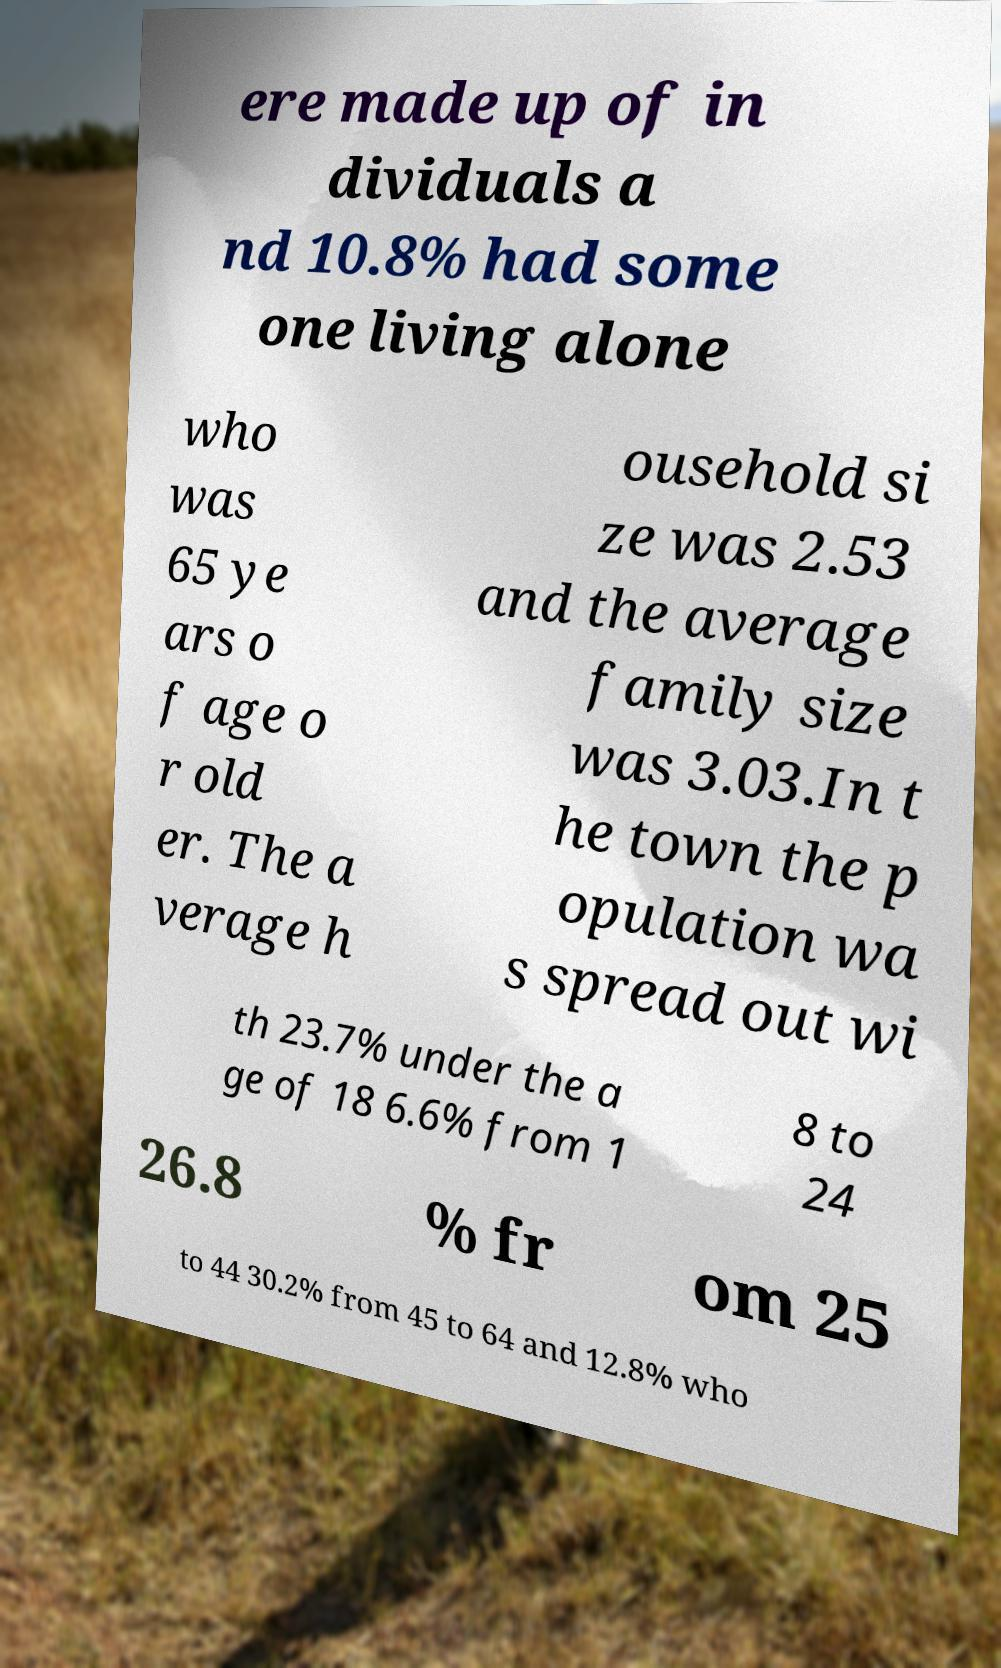Can you read and provide the text displayed in the image?This photo seems to have some interesting text. Can you extract and type it out for me? ere made up of in dividuals a nd 10.8% had some one living alone who was 65 ye ars o f age o r old er. The a verage h ousehold si ze was 2.53 and the average family size was 3.03.In t he town the p opulation wa s spread out wi th 23.7% under the a ge of 18 6.6% from 1 8 to 24 26.8 % fr om 25 to 44 30.2% from 45 to 64 and 12.8% who 